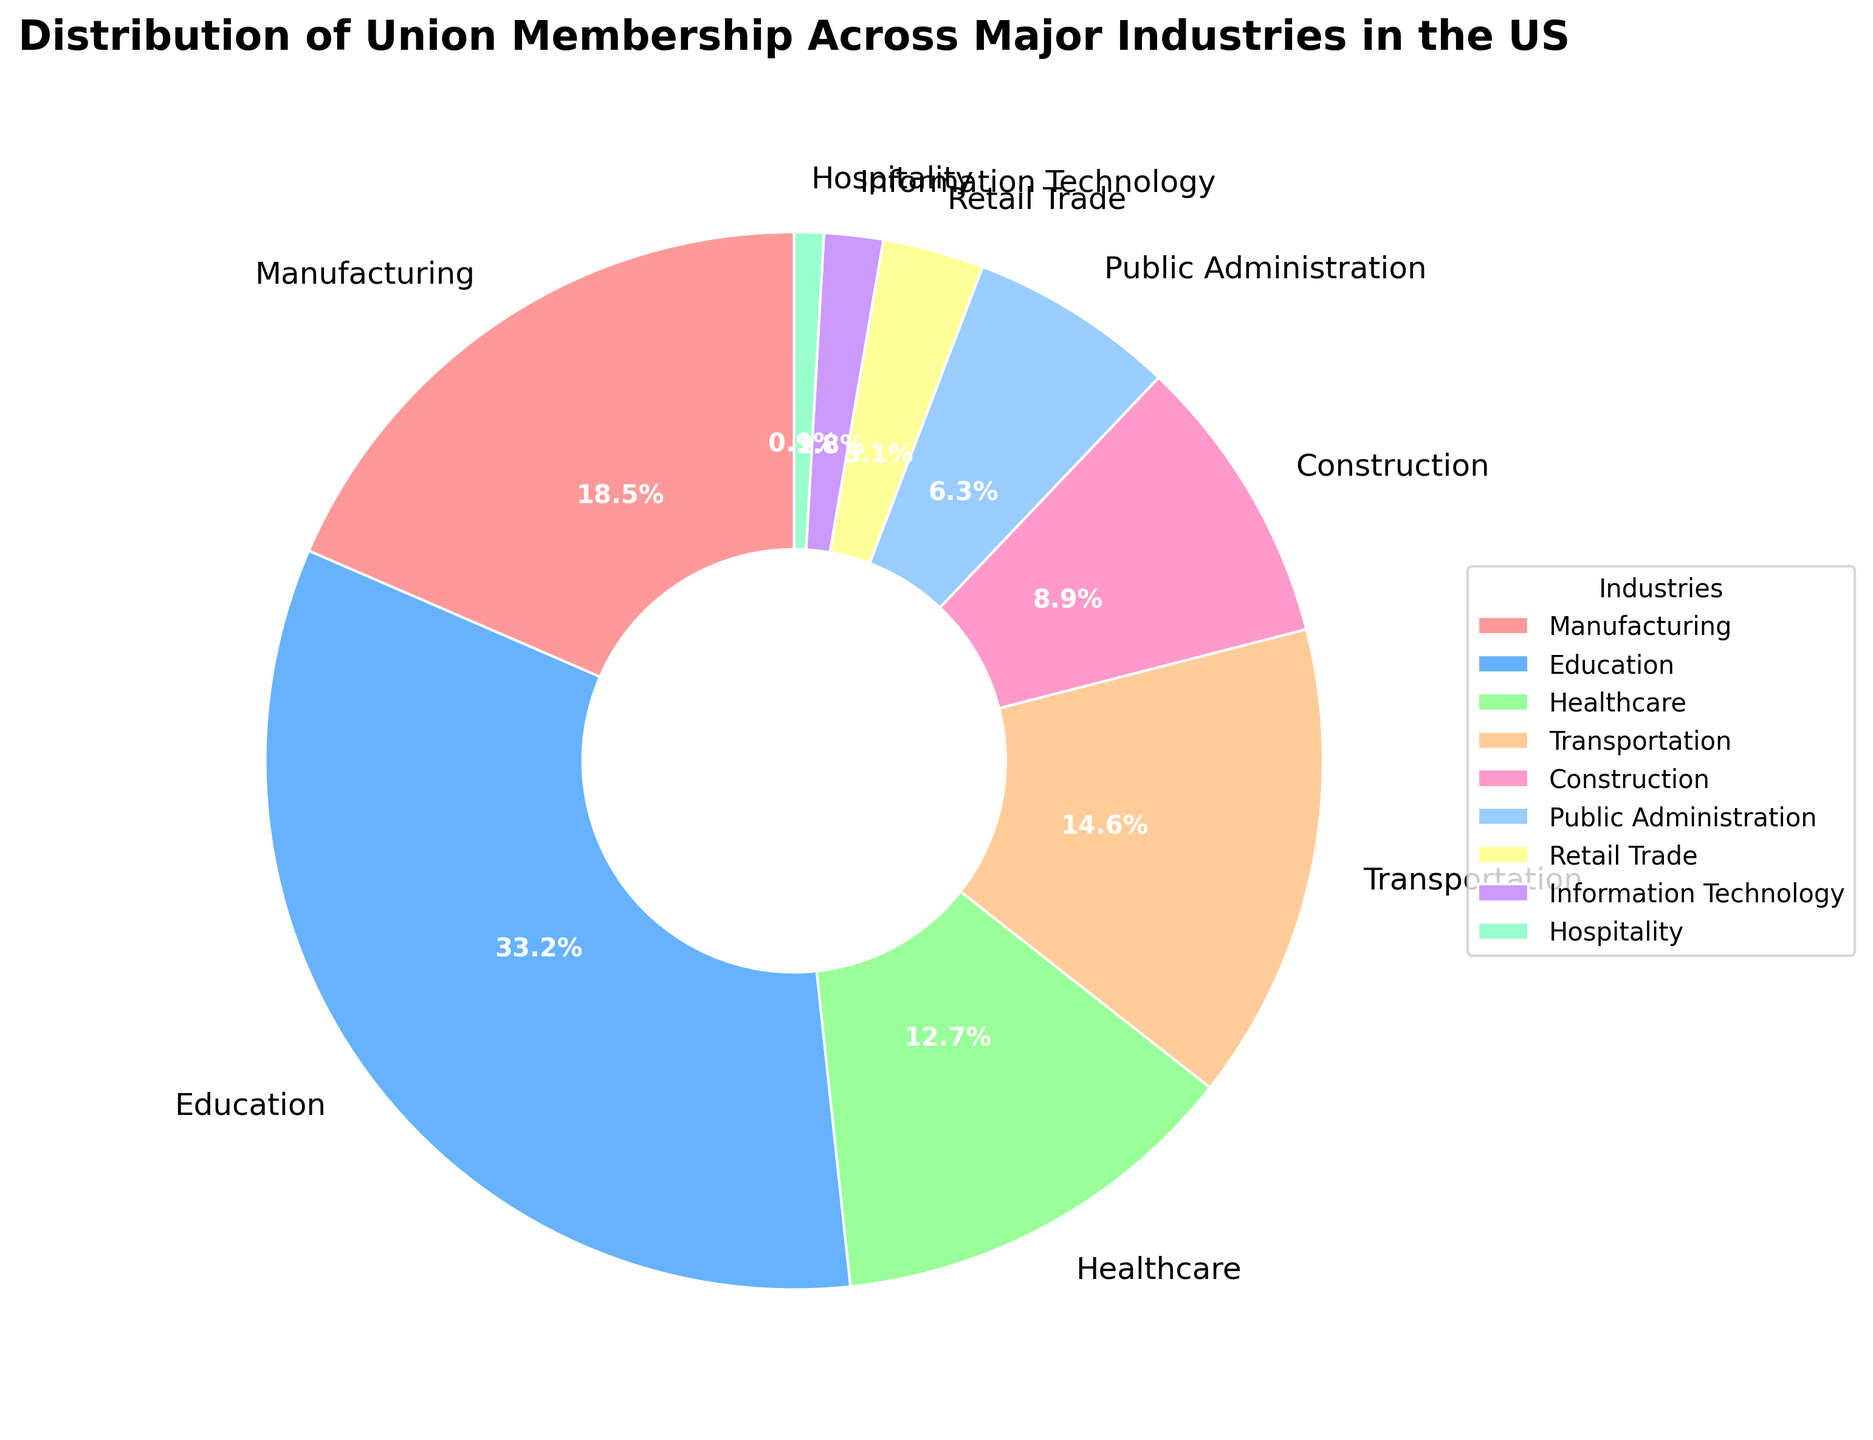What's the largest industry by union membership percentage? By looking at the pie chart, the sector with the largest visual slice represents the highest percentage of union membership.
Answer: Education Which industry has the smallest percentage of union membership? The smallest wedge in the pie chart indicates the lowest union membership percentage.
Answer: Hospitality What is the combined union membership percentage of the Manufacturing and Healthcare industries? Add the percentages for Manufacturing (18.5%) and Healthcare (12.7%), resulting in 18.5 + 12.7 = 31.2%.
Answer: 31.2% Which sectors have union membership percentages greater than 10% but less than 20%? Identify the wedges that fall within the 10% to 20% range by comparing their sizes to sector labels on the chart.
Answer: Manufacturing, Transportation, Healthcare How much greater is the union membership percentage in Education compared to Retail Trade? Subtract the percentage of Retail Trade (3.1%) from Education (33.2%) resulting in 33.2 - 3.1 = 30.1%.
Answer: 30.1% Which color represents the Transportation industry in the pie chart? Locate the Transportation label on the chart and note the corresponding color slice.
Answer: Light Blue (as provided by the custom color code) What is the difference in union membership percentage between Public Administration and Construction? Subtract the percentage of Public Administration (6.3%) from Construction (8.9%), resulting in 8.9 - 6.3 = 2.6%.
Answer: 2.6% What proportion of union membership does the Information Technology sector hold in relation to total union membership? The Information Technology wedge represents 1.8% of the entire chart, which is the proportion of union membership for this sector.
Answer: 1.8% Between which two sectors is the percentage difference the smallest? Review the pie chart wedges and calculate the differences between the closest percentages. The smallest difference is between Construction (8.9%) and Public Administration (6.3%), resulting in 8.9 - 6.3 = 2.6%.
Answer: Construction and Public Administration What percentage of union membership is accounted for by industries with percentages less than or equal to 10%? Sum the percentages for Construction (8.9%), Public Administration (6.3%), Retail Trade (3.1%), Information Technology (1.8%), and Hospitality (0.9%) resulting in 8.9 + 6.3 + 3.1 + 1.8 + 0.9 = 21%.
Answer: 21% 